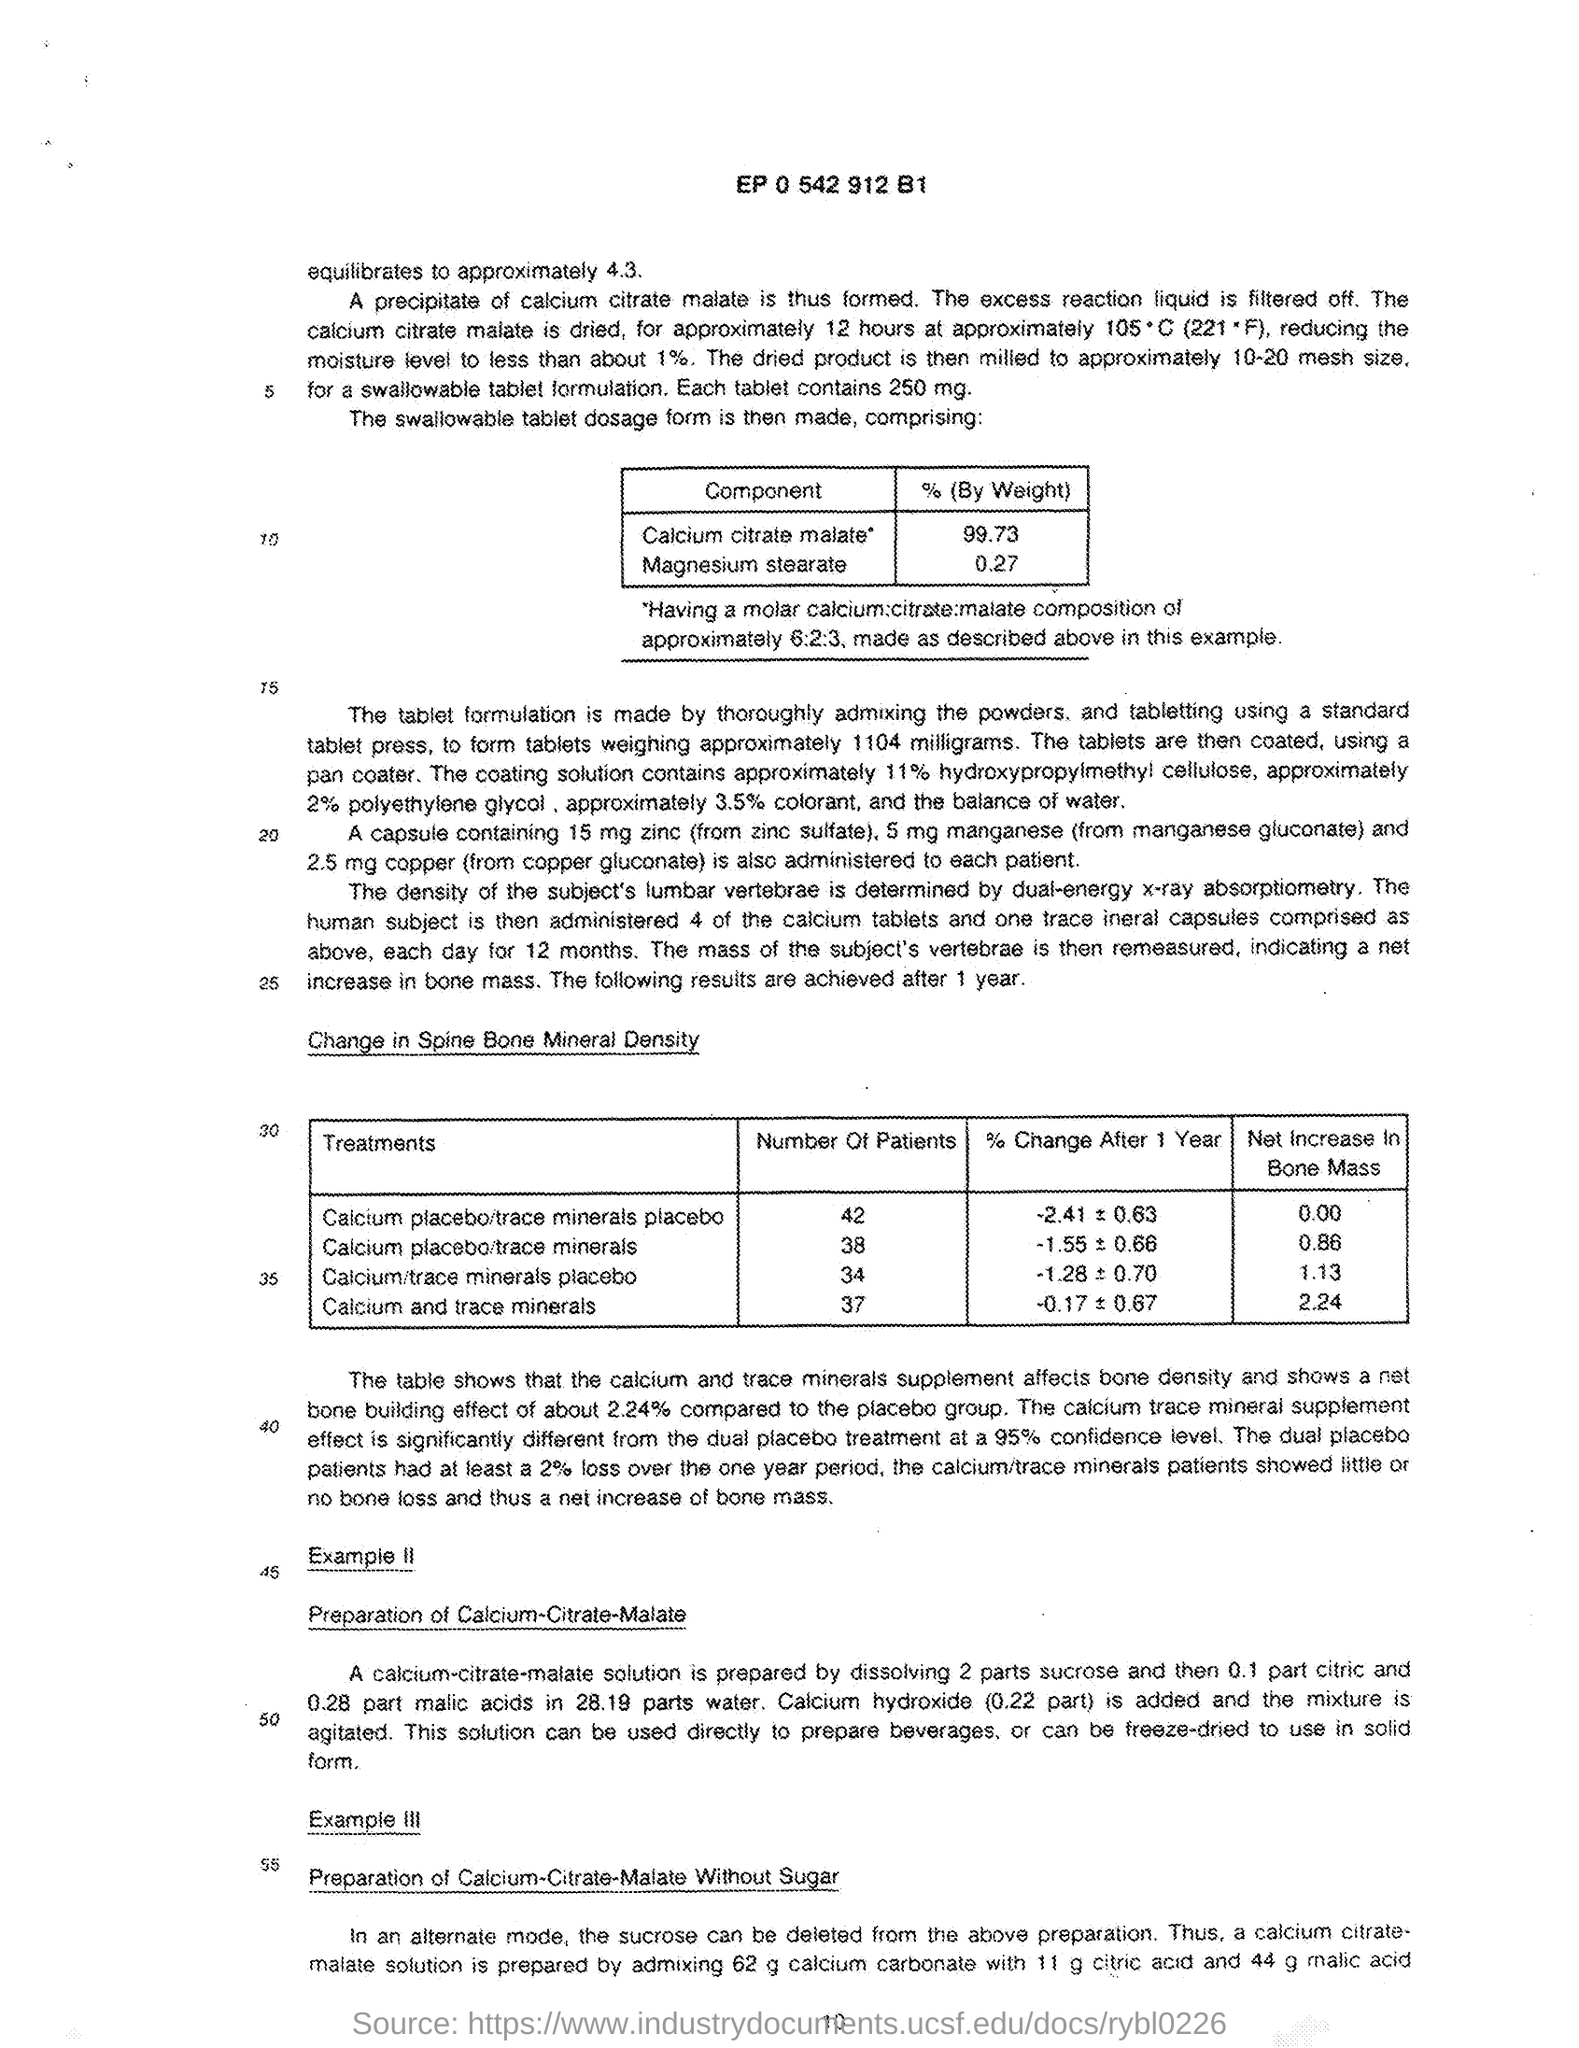What is the percentage of Calcium citrate malate?
Your answer should be compact. 99.73. What is the percentage of Magnesium stearate?
Offer a very short reply. 0.27. What is the number at the top of the document?
Your response must be concise. EP 0 542 912 B1. What is the number of patients for the treatment of "calcium and trace minerals"?
Offer a very short reply. 37. What is the number of patients for the treatment of "calcium/trace minerals placebo"?
Provide a succinct answer. 34. 